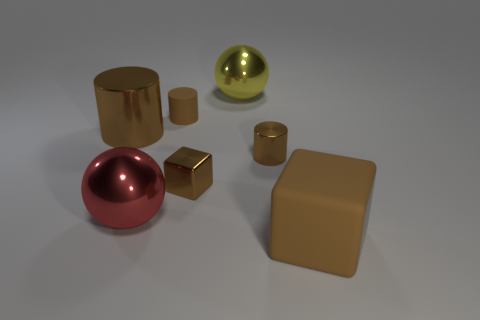Add 2 large red metallic cylinders. How many objects exist? 9 Subtract all cubes. How many objects are left? 5 Add 1 big blocks. How many big blocks are left? 2 Add 4 spheres. How many spheres exist? 6 Subtract 0 gray cylinders. How many objects are left? 7 Subtract all large red spheres. Subtract all large matte things. How many objects are left? 5 